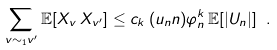Convert formula to latex. <formula><loc_0><loc_0><loc_500><loc_500>\sum _ { v \sim _ { 1 } v ^ { \prime } } \mathbb { E } [ X _ { v } \, X _ { v ^ { \prime } } ] \leq c _ { k } \, ( u _ { n } n ) \varphi _ { n } ^ { k } \, \mathbb { E } [ | U _ { n } | ] \ .</formula> 